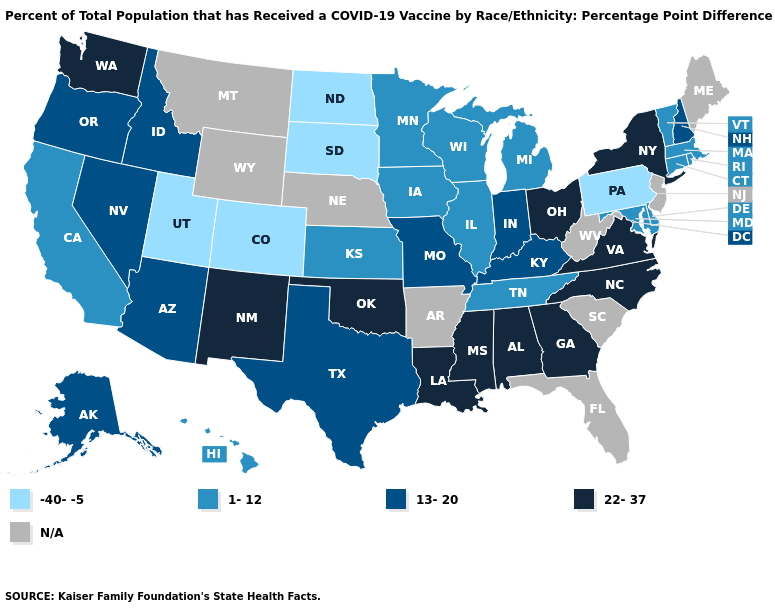What is the value of Kentucky?
Write a very short answer. 13-20. What is the highest value in the USA?
Be succinct. 22-37. Does the map have missing data?
Give a very brief answer. Yes. Does Washington have the highest value in the West?
Be succinct. Yes. Among the states that border Wisconsin , which have the highest value?
Write a very short answer. Illinois, Iowa, Michigan, Minnesota. Which states have the lowest value in the USA?
Concise answer only. Colorado, North Dakota, Pennsylvania, South Dakota, Utah. How many symbols are there in the legend?
Short answer required. 5. What is the lowest value in states that border Delaware?
Give a very brief answer. -40--5. Name the states that have a value in the range -40--5?
Quick response, please. Colorado, North Dakota, Pennsylvania, South Dakota, Utah. What is the highest value in the West ?
Concise answer only. 22-37. Name the states that have a value in the range 1-12?
Concise answer only. California, Connecticut, Delaware, Hawaii, Illinois, Iowa, Kansas, Maryland, Massachusetts, Michigan, Minnesota, Rhode Island, Tennessee, Vermont, Wisconsin. Does Maryland have the highest value in the USA?
Give a very brief answer. No. What is the value of Arizona?
Concise answer only. 13-20. What is the value of Utah?
Be succinct. -40--5. 